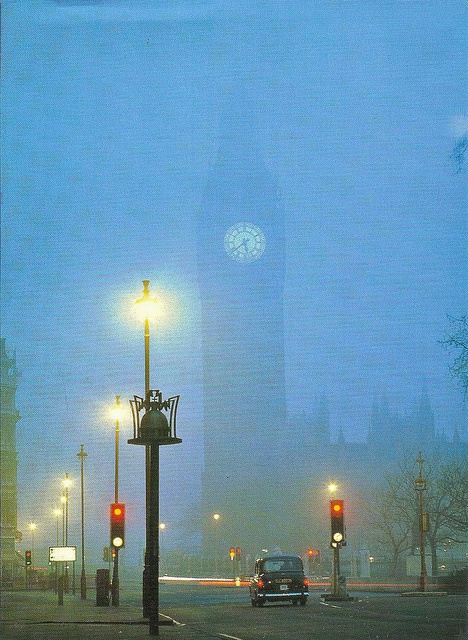Describe the objects in this image and their specific colors. I can see car in gray, black, teal, and darkgreen tones, clock in gray, lightblue, and darkgray tones, traffic light in gray, maroon, and black tones, traffic light in gray, maroon, and brown tones, and traffic light in gray, darkgreen, black, and olive tones in this image. 